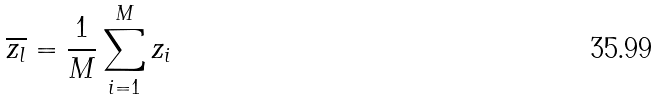<formula> <loc_0><loc_0><loc_500><loc_500>\overline { z _ { l } } = \frac { 1 } { M } \sum _ { i = 1 } ^ { M } z _ { i }</formula> 